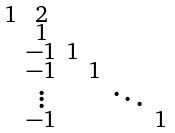Convert formula to latex. <formula><loc_0><loc_0><loc_500><loc_500>\begin{smallmatrix} 1 & 2 & & & & \\ & 1 & & & & \\ & - 1 & 1 & & & \\ & - 1 & & 1 & & \\ & \vdots & & & \ddots & \\ & - 1 & & & & 1 \\ \end{smallmatrix}</formula> 